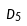Convert formula to latex. <formula><loc_0><loc_0><loc_500><loc_500>\tilde { D } _ { 5 }</formula> 